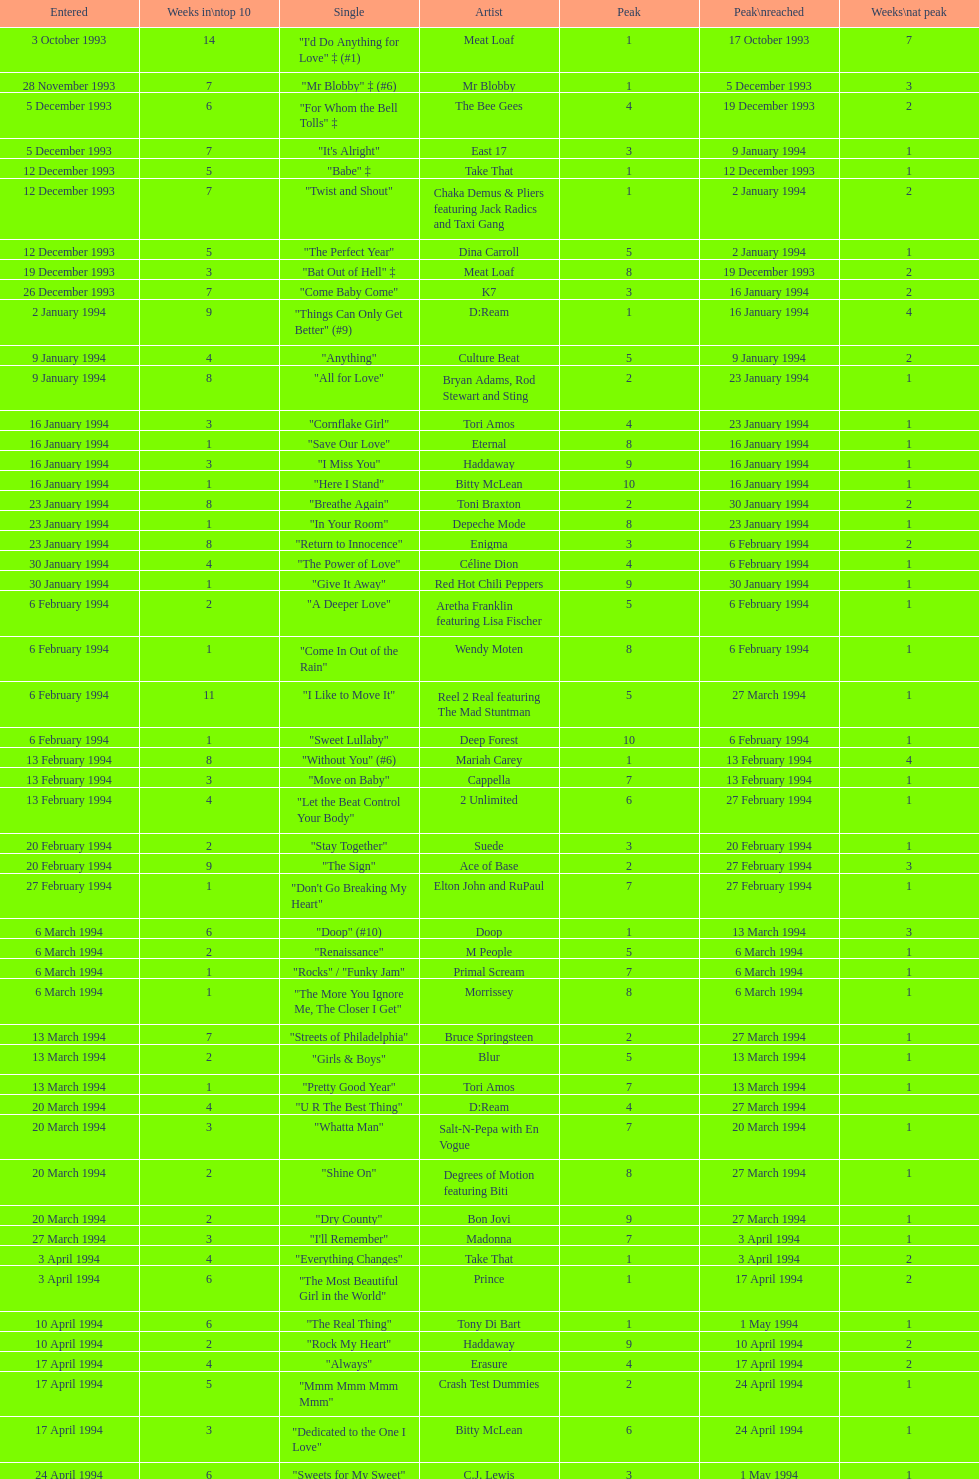Which artist only has its single entered on 2 january 1994? D:Ream. 